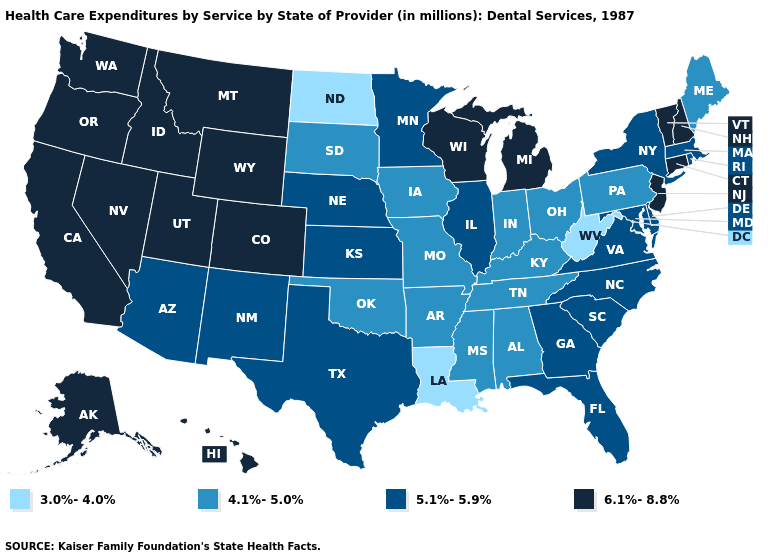What is the lowest value in the USA?
Answer briefly. 3.0%-4.0%. What is the value of Connecticut?
Give a very brief answer. 6.1%-8.8%. Name the states that have a value in the range 5.1%-5.9%?
Give a very brief answer. Arizona, Delaware, Florida, Georgia, Illinois, Kansas, Maryland, Massachusetts, Minnesota, Nebraska, New Mexico, New York, North Carolina, Rhode Island, South Carolina, Texas, Virginia. Among the states that border Louisiana , does Arkansas have the highest value?
Give a very brief answer. No. Among the states that border Colorado , does Oklahoma have the lowest value?
Answer briefly. Yes. What is the highest value in states that border Nebraska?
Concise answer only. 6.1%-8.8%. What is the lowest value in states that border Rhode Island?
Concise answer only. 5.1%-5.9%. Does Wisconsin have the highest value in the USA?
Short answer required. Yes. Among the states that border Rhode Island , does Connecticut have the lowest value?
Keep it brief. No. Which states have the highest value in the USA?
Write a very short answer. Alaska, California, Colorado, Connecticut, Hawaii, Idaho, Michigan, Montana, Nevada, New Hampshire, New Jersey, Oregon, Utah, Vermont, Washington, Wisconsin, Wyoming. Does the map have missing data?
Concise answer only. No. What is the value of Wyoming?
Give a very brief answer. 6.1%-8.8%. What is the value of Minnesota?
Be succinct. 5.1%-5.9%. Name the states that have a value in the range 4.1%-5.0%?
Keep it brief. Alabama, Arkansas, Indiana, Iowa, Kentucky, Maine, Mississippi, Missouri, Ohio, Oklahoma, Pennsylvania, South Dakota, Tennessee. Which states hav the highest value in the Northeast?
Be succinct. Connecticut, New Hampshire, New Jersey, Vermont. 